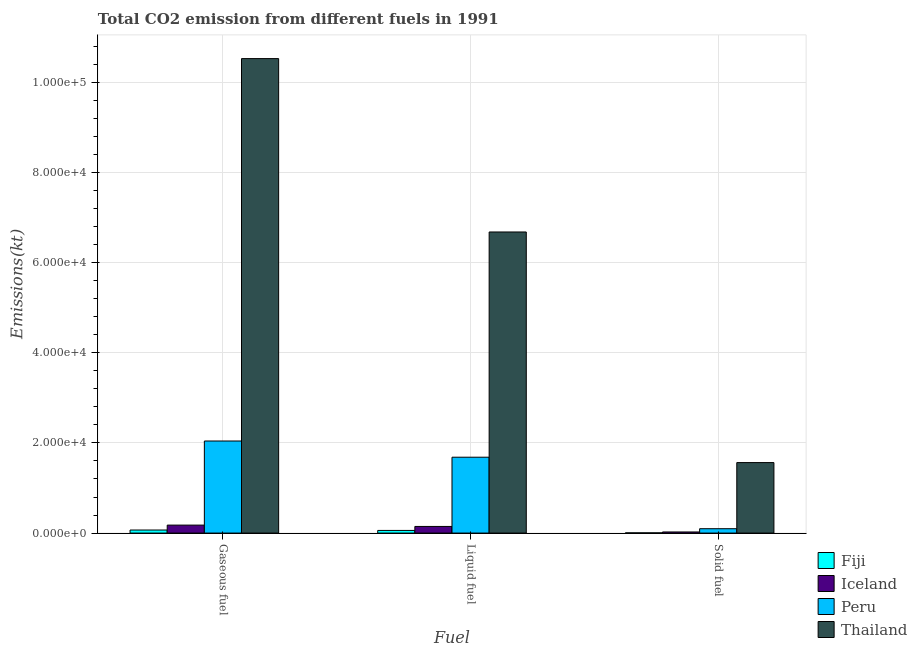How many different coloured bars are there?
Your answer should be very brief. 4. Are the number of bars per tick equal to the number of legend labels?
Your answer should be compact. Yes. How many bars are there on the 2nd tick from the right?
Your answer should be very brief. 4. What is the label of the 2nd group of bars from the left?
Make the answer very short. Liquid fuel. What is the amount of co2 emissions from gaseous fuel in Thailand?
Your answer should be compact. 1.05e+05. Across all countries, what is the maximum amount of co2 emissions from gaseous fuel?
Keep it short and to the point. 1.05e+05. Across all countries, what is the minimum amount of co2 emissions from liquid fuel?
Give a very brief answer. 586.72. In which country was the amount of co2 emissions from solid fuel maximum?
Provide a short and direct response. Thailand. In which country was the amount of co2 emissions from solid fuel minimum?
Offer a terse response. Fiji. What is the total amount of co2 emissions from solid fuel in the graph?
Provide a short and direct response. 1.69e+04. What is the difference between the amount of co2 emissions from liquid fuel in Peru and that in Fiji?
Make the answer very short. 1.62e+04. What is the difference between the amount of co2 emissions from solid fuel in Thailand and the amount of co2 emissions from gaseous fuel in Peru?
Provide a short and direct response. -4785.43. What is the average amount of co2 emissions from gaseous fuel per country?
Provide a succinct answer. 3.20e+04. What is the difference between the amount of co2 emissions from solid fuel and amount of co2 emissions from liquid fuel in Thailand?
Ensure brevity in your answer.  -5.11e+04. In how many countries, is the amount of co2 emissions from solid fuel greater than 68000 kt?
Give a very brief answer. 0. What is the ratio of the amount of co2 emissions from solid fuel in Fiji to that in Iceland?
Provide a short and direct response. 0.19. Is the amount of co2 emissions from solid fuel in Thailand less than that in Fiji?
Provide a short and direct response. No. What is the difference between the highest and the second highest amount of co2 emissions from liquid fuel?
Offer a very short reply. 5.00e+04. What is the difference between the highest and the lowest amount of co2 emissions from liquid fuel?
Offer a very short reply. 6.62e+04. In how many countries, is the amount of co2 emissions from liquid fuel greater than the average amount of co2 emissions from liquid fuel taken over all countries?
Your response must be concise. 1. Is the sum of the amount of co2 emissions from liquid fuel in Peru and Fiji greater than the maximum amount of co2 emissions from gaseous fuel across all countries?
Offer a terse response. No. Are all the bars in the graph horizontal?
Keep it short and to the point. No. How many countries are there in the graph?
Offer a very short reply. 4. What is the difference between two consecutive major ticks on the Y-axis?
Your answer should be compact. 2.00e+04. Are the values on the major ticks of Y-axis written in scientific E-notation?
Ensure brevity in your answer.  Yes. Does the graph contain any zero values?
Make the answer very short. No. Where does the legend appear in the graph?
Offer a terse response. Bottom right. What is the title of the graph?
Provide a short and direct response. Total CO2 emission from different fuels in 1991. Does "Lithuania" appear as one of the legend labels in the graph?
Keep it short and to the point. No. What is the label or title of the X-axis?
Offer a very short reply. Fuel. What is the label or title of the Y-axis?
Provide a short and direct response. Emissions(kt). What is the Emissions(kt) of Fiji in Gaseous fuel?
Provide a succinct answer. 674.73. What is the Emissions(kt) in Iceland in Gaseous fuel?
Your response must be concise. 1767.49. What is the Emissions(kt) in Peru in Gaseous fuel?
Provide a short and direct response. 2.04e+04. What is the Emissions(kt) of Thailand in Gaseous fuel?
Ensure brevity in your answer.  1.05e+05. What is the Emissions(kt) in Fiji in Liquid fuel?
Your answer should be very brief. 586.72. What is the Emissions(kt) of Iceland in Liquid fuel?
Give a very brief answer. 1470.47. What is the Emissions(kt) of Peru in Liquid fuel?
Keep it short and to the point. 1.68e+04. What is the Emissions(kt) in Thailand in Liquid fuel?
Your answer should be very brief. 6.68e+04. What is the Emissions(kt) of Fiji in Solid fuel?
Give a very brief answer. 47.67. What is the Emissions(kt) of Iceland in Solid fuel?
Your response must be concise. 245.69. What is the Emissions(kt) in Peru in Solid fuel?
Keep it short and to the point. 968.09. What is the Emissions(kt) in Thailand in Solid fuel?
Your response must be concise. 1.56e+04. Across all Fuel, what is the maximum Emissions(kt) of Fiji?
Provide a short and direct response. 674.73. Across all Fuel, what is the maximum Emissions(kt) of Iceland?
Your response must be concise. 1767.49. Across all Fuel, what is the maximum Emissions(kt) of Peru?
Make the answer very short. 2.04e+04. Across all Fuel, what is the maximum Emissions(kt) in Thailand?
Provide a short and direct response. 1.05e+05. Across all Fuel, what is the minimum Emissions(kt) of Fiji?
Offer a terse response. 47.67. Across all Fuel, what is the minimum Emissions(kt) of Iceland?
Your answer should be very brief. 245.69. Across all Fuel, what is the minimum Emissions(kt) of Peru?
Offer a terse response. 968.09. Across all Fuel, what is the minimum Emissions(kt) of Thailand?
Provide a short and direct response. 1.56e+04. What is the total Emissions(kt) of Fiji in the graph?
Make the answer very short. 1309.12. What is the total Emissions(kt) of Iceland in the graph?
Your response must be concise. 3483.65. What is the total Emissions(kt) in Peru in the graph?
Your response must be concise. 3.82e+04. What is the total Emissions(kt) of Thailand in the graph?
Your answer should be compact. 1.88e+05. What is the difference between the Emissions(kt) in Fiji in Gaseous fuel and that in Liquid fuel?
Your response must be concise. 88.01. What is the difference between the Emissions(kt) in Iceland in Gaseous fuel and that in Liquid fuel?
Give a very brief answer. 297.03. What is the difference between the Emissions(kt) in Peru in Gaseous fuel and that in Liquid fuel?
Your answer should be compact. 3593.66. What is the difference between the Emissions(kt) of Thailand in Gaseous fuel and that in Liquid fuel?
Offer a very short reply. 3.85e+04. What is the difference between the Emissions(kt) in Fiji in Gaseous fuel and that in Solid fuel?
Provide a succinct answer. 627.06. What is the difference between the Emissions(kt) in Iceland in Gaseous fuel and that in Solid fuel?
Make the answer very short. 1521.81. What is the difference between the Emissions(kt) in Peru in Gaseous fuel and that in Solid fuel?
Make the answer very short. 1.94e+04. What is the difference between the Emissions(kt) in Thailand in Gaseous fuel and that in Solid fuel?
Offer a very short reply. 8.96e+04. What is the difference between the Emissions(kt) in Fiji in Liquid fuel and that in Solid fuel?
Offer a very short reply. 539.05. What is the difference between the Emissions(kt) in Iceland in Liquid fuel and that in Solid fuel?
Offer a very short reply. 1224.78. What is the difference between the Emissions(kt) of Peru in Liquid fuel and that in Solid fuel?
Ensure brevity in your answer.  1.59e+04. What is the difference between the Emissions(kt) of Thailand in Liquid fuel and that in Solid fuel?
Your answer should be compact. 5.11e+04. What is the difference between the Emissions(kt) in Fiji in Gaseous fuel and the Emissions(kt) in Iceland in Liquid fuel?
Keep it short and to the point. -795.74. What is the difference between the Emissions(kt) in Fiji in Gaseous fuel and the Emissions(kt) in Peru in Liquid fuel?
Offer a terse response. -1.61e+04. What is the difference between the Emissions(kt) in Fiji in Gaseous fuel and the Emissions(kt) in Thailand in Liquid fuel?
Give a very brief answer. -6.61e+04. What is the difference between the Emissions(kt) of Iceland in Gaseous fuel and the Emissions(kt) of Peru in Liquid fuel?
Provide a succinct answer. -1.51e+04. What is the difference between the Emissions(kt) of Iceland in Gaseous fuel and the Emissions(kt) of Thailand in Liquid fuel?
Ensure brevity in your answer.  -6.50e+04. What is the difference between the Emissions(kt) of Peru in Gaseous fuel and the Emissions(kt) of Thailand in Liquid fuel?
Keep it short and to the point. -4.64e+04. What is the difference between the Emissions(kt) of Fiji in Gaseous fuel and the Emissions(kt) of Iceland in Solid fuel?
Provide a short and direct response. 429.04. What is the difference between the Emissions(kt) in Fiji in Gaseous fuel and the Emissions(kt) in Peru in Solid fuel?
Make the answer very short. -293.36. What is the difference between the Emissions(kt) of Fiji in Gaseous fuel and the Emissions(kt) of Thailand in Solid fuel?
Provide a succinct answer. -1.50e+04. What is the difference between the Emissions(kt) in Iceland in Gaseous fuel and the Emissions(kt) in Peru in Solid fuel?
Provide a short and direct response. 799.41. What is the difference between the Emissions(kt) of Iceland in Gaseous fuel and the Emissions(kt) of Thailand in Solid fuel?
Keep it short and to the point. -1.39e+04. What is the difference between the Emissions(kt) of Peru in Gaseous fuel and the Emissions(kt) of Thailand in Solid fuel?
Your response must be concise. 4785.44. What is the difference between the Emissions(kt) of Fiji in Liquid fuel and the Emissions(kt) of Iceland in Solid fuel?
Your answer should be very brief. 341.03. What is the difference between the Emissions(kt) in Fiji in Liquid fuel and the Emissions(kt) in Peru in Solid fuel?
Keep it short and to the point. -381.37. What is the difference between the Emissions(kt) of Fiji in Liquid fuel and the Emissions(kt) of Thailand in Solid fuel?
Your response must be concise. -1.50e+04. What is the difference between the Emissions(kt) in Iceland in Liquid fuel and the Emissions(kt) in Peru in Solid fuel?
Offer a very short reply. 502.38. What is the difference between the Emissions(kt) in Iceland in Liquid fuel and the Emissions(kt) in Thailand in Solid fuel?
Offer a very short reply. -1.42e+04. What is the difference between the Emissions(kt) of Peru in Liquid fuel and the Emissions(kt) of Thailand in Solid fuel?
Your answer should be very brief. 1191.78. What is the average Emissions(kt) in Fiji per Fuel?
Ensure brevity in your answer.  436.37. What is the average Emissions(kt) in Iceland per Fuel?
Keep it short and to the point. 1161.22. What is the average Emissions(kt) of Peru per Fuel?
Keep it short and to the point. 1.27e+04. What is the average Emissions(kt) in Thailand per Fuel?
Offer a very short reply. 6.25e+04. What is the difference between the Emissions(kt) in Fiji and Emissions(kt) in Iceland in Gaseous fuel?
Your answer should be very brief. -1092.77. What is the difference between the Emissions(kt) of Fiji and Emissions(kt) of Peru in Gaseous fuel?
Provide a succinct answer. -1.97e+04. What is the difference between the Emissions(kt) of Fiji and Emissions(kt) of Thailand in Gaseous fuel?
Provide a succinct answer. -1.05e+05. What is the difference between the Emissions(kt) of Iceland and Emissions(kt) of Peru in Gaseous fuel?
Your answer should be compact. -1.87e+04. What is the difference between the Emissions(kt) of Iceland and Emissions(kt) of Thailand in Gaseous fuel?
Give a very brief answer. -1.03e+05. What is the difference between the Emissions(kt) of Peru and Emissions(kt) of Thailand in Gaseous fuel?
Your answer should be very brief. -8.48e+04. What is the difference between the Emissions(kt) of Fiji and Emissions(kt) of Iceland in Liquid fuel?
Make the answer very short. -883.75. What is the difference between the Emissions(kt) of Fiji and Emissions(kt) of Peru in Liquid fuel?
Ensure brevity in your answer.  -1.62e+04. What is the difference between the Emissions(kt) of Fiji and Emissions(kt) of Thailand in Liquid fuel?
Ensure brevity in your answer.  -6.62e+04. What is the difference between the Emissions(kt) in Iceland and Emissions(kt) in Peru in Liquid fuel?
Provide a succinct answer. -1.54e+04. What is the difference between the Emissions(kt) of Iceland and Emissions(kt) of Thailand in Liquid fuel?
Make the answer very short. -6.53e+04. What is the difference between the Emissions(kt) in Peru and Emissions(kt) in Thailand in Liquid fuel?
Offer a terse response. -5.00e+04. What is the difference between the Emissions(kt) in Fiji and Emissions(kt) in Iceland in Solid fuel?
Give a very brief answer. -198.02. What is the difference between the Emissions(kt) in Fiji and Emissions(kt) in Peru in Solid fuel?
Offer a very short reply. -920.42. What is the difference between the Emissions(kt) of Fiji and Emissions(kt) of Thailand in Solid fuel?
Make the answer very short. -1.56e+04. What is the difference between the Emissions(kt) in Iceland and Emissions(kt) in Peru in Solid fuel?
Your answer should be very brief. -722.4. What is the difference between the Emissions(kt) in Iceland and Emissions(kt) in Thailand in Solid fuel?
Provide a succinct answer. -1.54e+04. What is the difference between the Emissions(kt) of Peru and Emissions(kt) of Thailand in Solid fuel?
Provide a short and direct response. -1.47e+04. What is the ratio of the Emissions(kt) of Fiji in Gaseous fuel to that in Liquid fuel?
Ensure brevity in your answer.  1.15. What is the ratio of the Emissions(kt) of Iceland in Gaseous fuel to that in Liquid fuel?
Provide a succinct answer. 1.2. What is the ratio of the Emissions(kt) in Peru in Gaseous fuel to that in Liquid fuel?
Your answer should be very brief. 1.21. What is the ratio of the Emissions(kt) in Thailand in Gaseous fuel to that in Liquid fuel?
Provide a short and direct response. 1.58. What is the ratio of the Emissions(kt) of Fiji in Gaseous fuel to that in Solid fuel?
Your response must be concise. 14.15. What is the ratio of the Emissions(kt) in Iceland in Gaseous fuel to that in Solid fuel?
Offer a terse response. 7.19. What is the ratio of the Emissions(kt) in Peru in Gaseous fuel to that in Solid fuel?
Provide a short and direct response. 21.09. What is the ratio of the Emissions(kt) in Thailand in Gaseous fuel to that in Solid fuel?
Make the answer very short. 6.73. What is the ratio of the Emissions(kt) of Fiji in Liquid fuel to that in Solid fuel?
Offer a very short reply. 12.31. What is the ratio of the Emissions(kt) of Iceland in Liquid fuel to that in Solid fuel?
Your response must be concise. 5.99. What is the ratio of the Emissions(kt) in Peru in Liquid fuel to that in Solid fuel?
Offer a terse response. 17.38. What is the ratio of the Emissions(kt) in Thailand in Liquid fuel to that in Solid fuel?
Provide a short and direct response. 4.27. What is the difference between the highest and the second highest Emissions(kt) in Fiji?
Offer a very short reply. 88.01. What is the difference between the highest and the second highest Emissions(kt) in Iceland?
Make the answer very short. 297.03. What is the difference between the highest and the second highest Emissions(kt) in Peru?
Ensure brevity in your answer.  3593.66. What is the difference between the highest and the second highest Emissions(kt) of Thailand?
Your response must be concise. 3.85e+04. What is the difference between the highest and the lowest Emissions(kt) of Fiji?
Provide a short and direct response. 627.06. What is the difference between the highest and the lowest Emissions(kt) in Iceland?
Your response must be concise. 1521.81. What is the difference between the highest and the lowest Emissions(kt) in Peru?
Offer a very short reply. 1.94e+04. What is the difference between the highest and the lowest Emissions(kt) in Thailand?
Keep it short and to the point. 8.96e+04. 